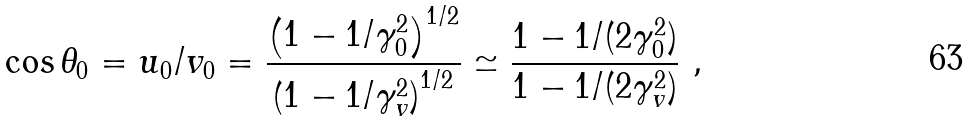Convert formula to latex. <formula><loc_0><loc_0><loc_500><loc_500>\cos { \theta _ { 0 } } = u _ { 0 } / v _ { 0 } = \frac { \left ( 1 - 1 / \gamma ^ { 2 } _ { 0 } \right ) ^ { 1 / 2 } } { \left ( 1 - 1 / \gamma ^ { 2 } _ { v } \right ) ^ { 1 / 2 } } \simeq \frac { 1 - 1 / ( 2 \gamma ^ { 2 } _ { 0 } ) } { 1 - 1 / ( 2 \gamma ^ { 2 } _ { v } ) } \ ,</formula> 